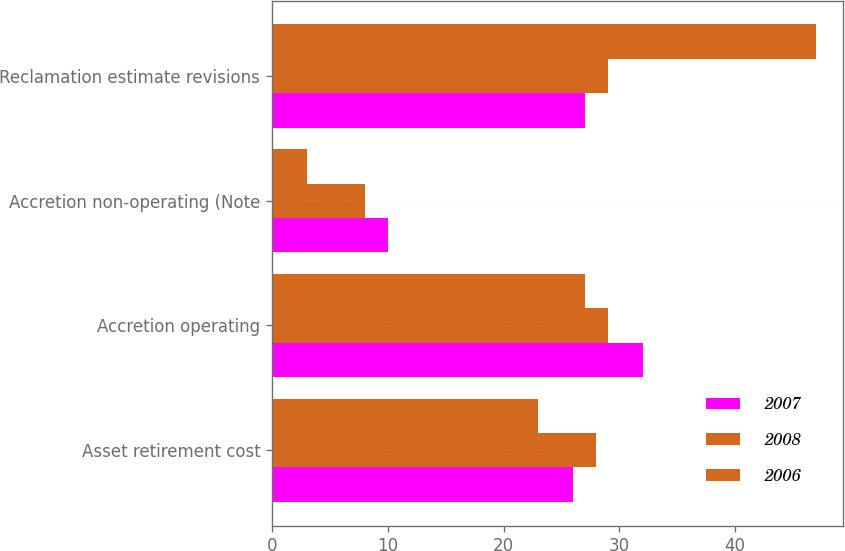Convert chart to OTSL. <chart><loc_0><loc_0><loc_500><loc_500><stacked_bar_chart><ecel><fcel>Asset retirement cost<fcel>Accretion operating<fcel>Accretion non-operating (Note<fcel>Reclamation estimate revisions<nl><fcel>2007<fcel>26<fcel>32<fcel>10<fcel>27<nl><fcel>2008<fcel>28<fcel>29<fcel>8<fcel>29<nl><fcel>2006<fcel>23<fcel>27<fcel>3<fcel>47<nl></chart> 